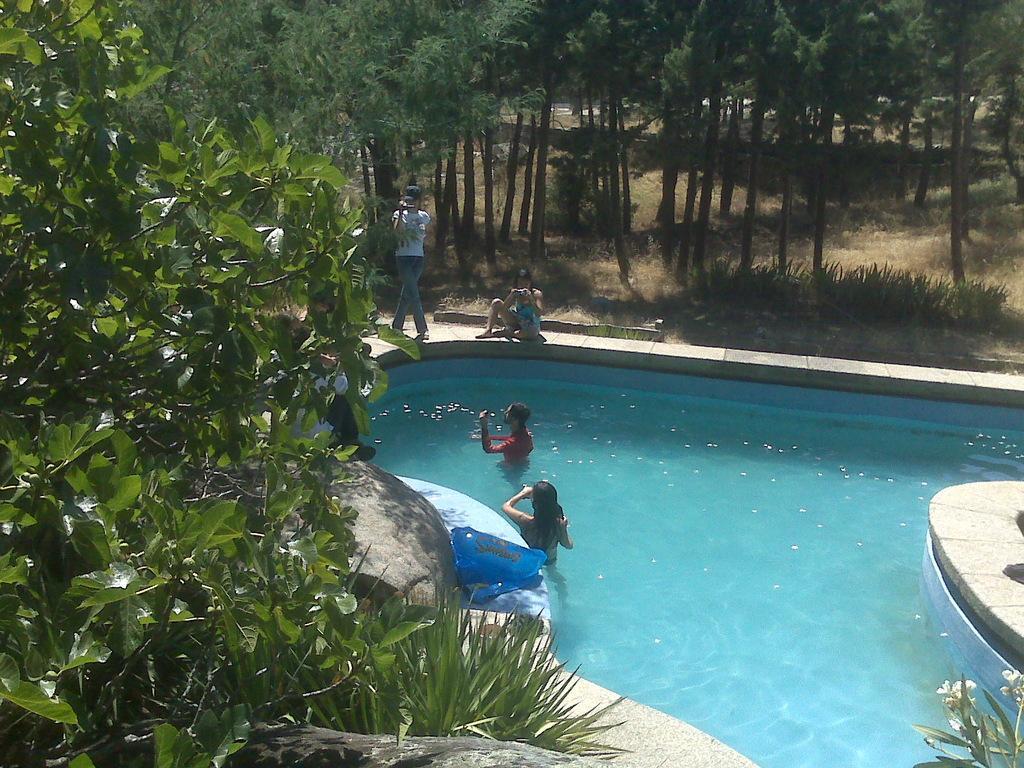Describe this image in one or two sentences. In this image we can see a swimming pool. There are two people in the pool. On the sides there are two people. Also there are trees. In the right bottom corner there is a plant with flowers. And there is a blue packet on the side of the pool. 